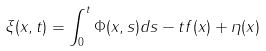Convert formula to latex. <formula><loc_0><loc_0><loc_500><loc_500>\xi ( x , t ) = \int _ { 0 } ^ { t } \Phi ( x , s ) d s - t f ( x ) + \eta ( x )</formula> 